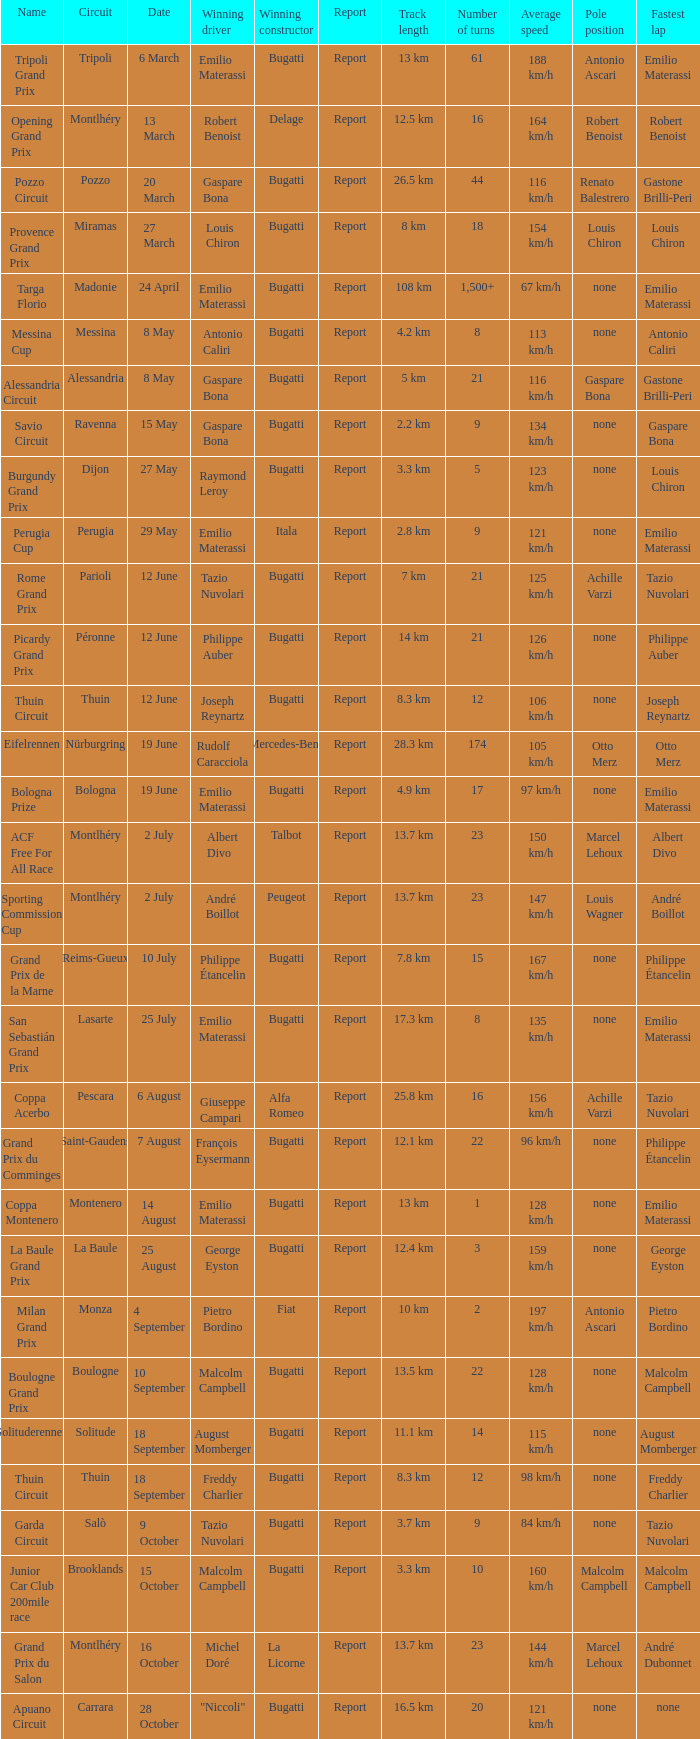When did Gaspare Bona win the Pozzo Circuit? 20 March. 